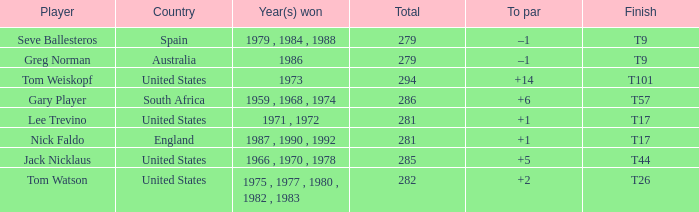Which country had a total of 282? United States. 